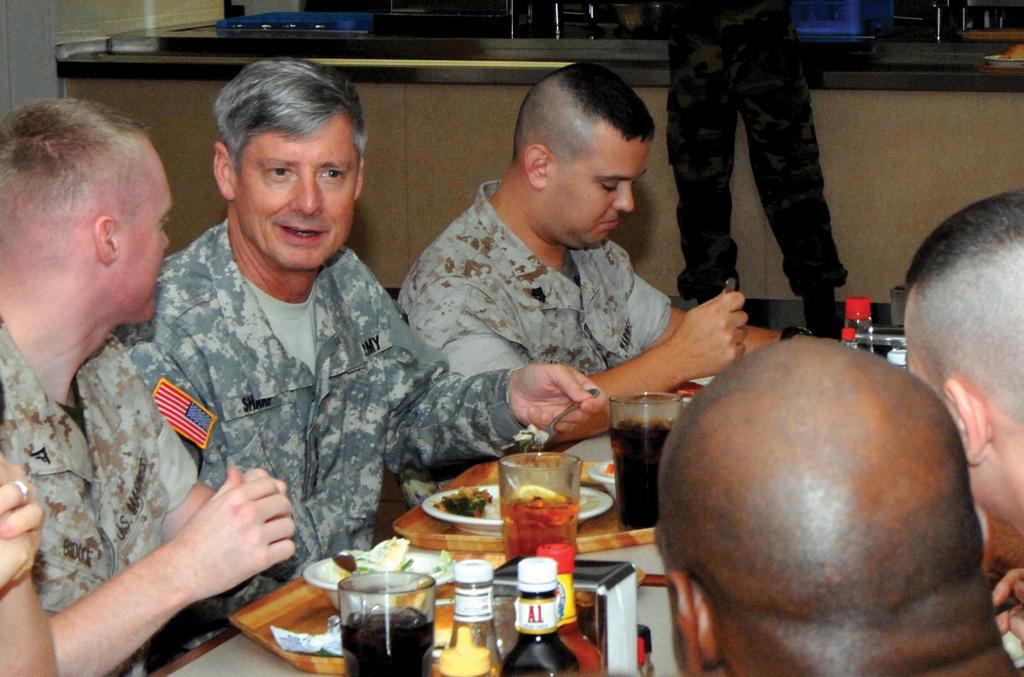Could you give a brief overview of what you see in this image? In this picture I can see few people seated and a man standing and I can see few bottles, glasses and few plates and bowls in the trays with some food and couple of them holding forks in their hands and I can see a bowl on the table and I can see a counter top. 